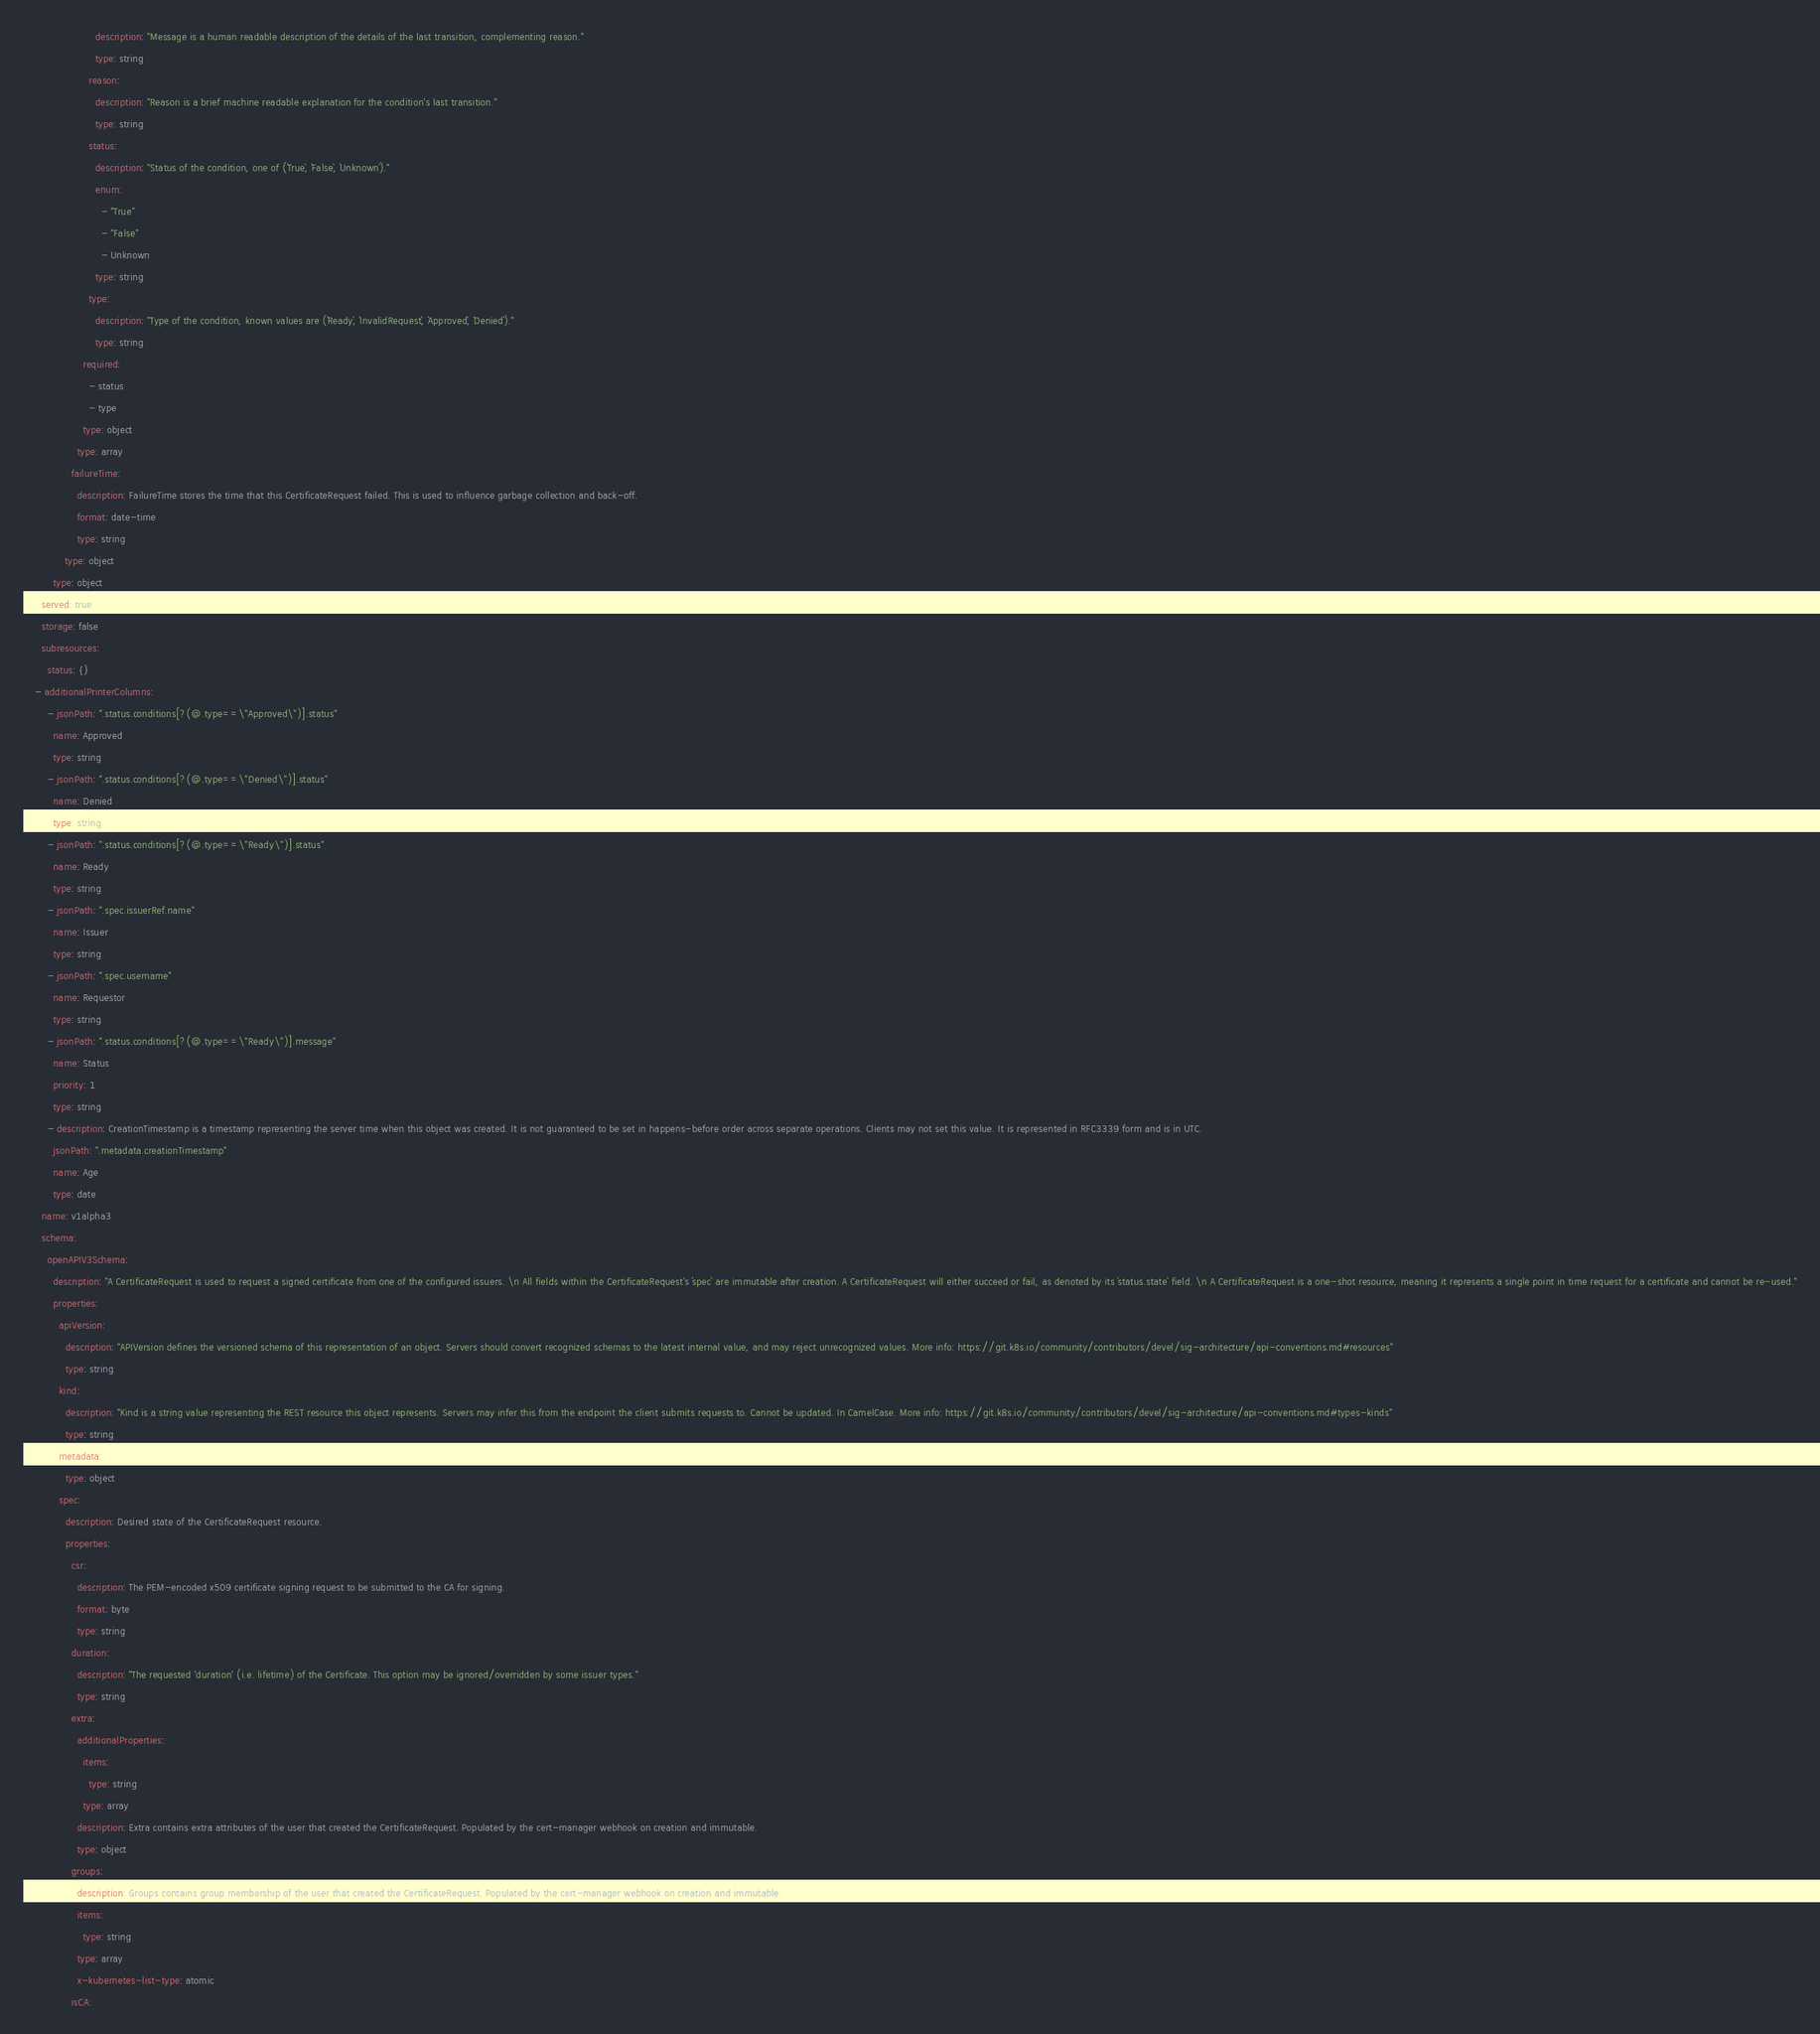<code> <loc_0><loc_0><loc_500><loc_500><_YAML_>                        description: "Message is a human readable description of the details of the last transition, complementing reason."
                        type: string
                      reason:
                        description: "Reason is a brief machine readable explanation for the condition's last transition."
                        type: string
                      status:
                        description: "Status of the condition, one of (`True`, `False`, `Unknown`)."
                        enum:
                          - "True"
                          - "False"
                          - Unknown
                        type: string
                      type:
                        description: "Type of the condition, known values are (`Ready`, `InvalidRequest`, `Approved`, `Denied`)."
                        type: string
                    required:
                      - status
                      - type
                    type: object
                  type: array
                failureTime:
                  description: FailureTime stores the time that this CertificateRequest failed. This is used to influence garbage collection and back-off.
                  format: date-time
                  type: string
              type: object
          type: object
      served: true
      storage: false
      subresources:
        status: {}
    - additionalPrinterColumns:
        - jsonPath: ".status.conditions[?(@.type==\"Approved\")].status"
          name: Approved
          type: string
        - jsonPath: ".status.conditions[?(@.type==\"Denied\")].status"
          name: Denied
          type: string
        - jsonPath: ".status.conditions[?(@.type==\"Ready\")].status"
          name: Ready
          type: string
        - jsonPath: ".spec.issuerRef.name"
          name: Issuer
          type: string
        - jsonPath: ".spec.username"
          name: Requestor
          type: string
        - jsonPath: ".status.conditions[?(@.type==\"Ready\")].message"
          name: Status
          priority: 1
          type: string
        - description: CreationTimestamp is a timestamp representing the server time when this object was created. It is not guaranteed to be set in happens-before order across separate operations. Clients may not set this value. It is represented in RFC3339 form and is in UTC.
          jsonPath: ".metadata.creationTimestamp"
          name: Age
          type: date
      name: v1alpha3
      schema:
        openAPIV3Schema:
          description: "A CertificateRequest is used to request a signed certificate from one of the configured issuers. \n All fields within the CertificateRequest's `spec` are immutable after creation. A CertificateRequest will either succeed or fail, as denoted by its `status.state` field. \n A CertificateRequest is a one-shot resource, meaning it represents a single point in time request for a certificate and cannot be re-used."
          properties:
            apiVersion:
              description: "APIVersion defines the versioned schema of this representation of an object. Servers should convert recognized schemas to the latest internal value, and may reject unrecognized values. More info: https://git.k8s.io/community/contributors/devel/sig-architecture/api-conventions.md#resources"
              type: string
            kind:
              description: "Kind is a string value representing the REST resource this object represents. Servers may infer this from the endpoint the client submits requests to. Cannot be updated. In CamelCase. More info: https://git.k8s.io/community/contributors/devel/sig-architecture/api-conventions.md#types-kinds"
              type: string
            metadata:
              type: object
            spec:
              description: Desired state of the CertificateRequest resource.
              properties:
                csr:
                  description: The PEM-encoded x509 certificate signing request to be submitted to the CA for signing.
                  format: byte
                  type: string
                duration:
                  description: "The requested 'duration' (i.e. lifetime) of the Certificate. This option may be ignored/overridden by some issuer types."
                  type: string
                extra:
                  additionalProperties:
                    items:
                      type: string
                    type: array
                  description: Extra contains extra attributes of the user that created the CertificateRequest. Populated by the cert-manager webhook on creation and immutable.
                  type: object
                groups:
                  description: Groups contains group membership of the user that created the CertificateRequest. Populated by the cert-manager webhook on creation and immutable.
                  items:
                    type: string
                  type: array
                  x-kubernetes-list-type: atomic
                isCA:</code> 